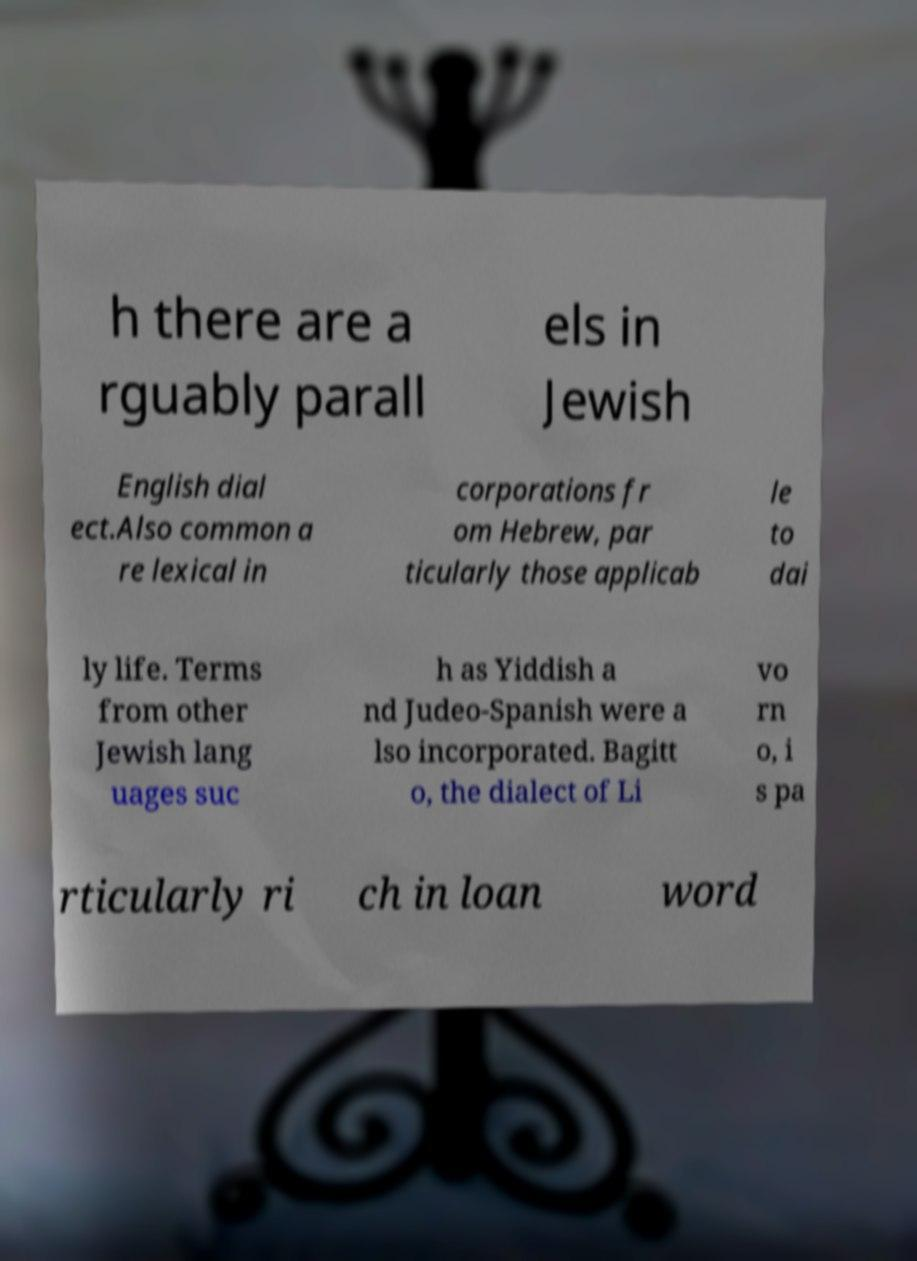Can you read and provide the text displayed in the image?This photo seems to have some interesting text. Can you extract and type it out for me? h there are a rguably parall els in Jewish English dial ect.Also common a re lexical in corporations fr om Hebrew, par ticularly those applicab le to dai ly life. Terms from other Jewish lang uages suc h as Yiddish a nd Judeo-Spanish were a lso incorporated. Bagitt o, the dialect of Li vo rn o, i s pa rticularly ri ch in loan word 